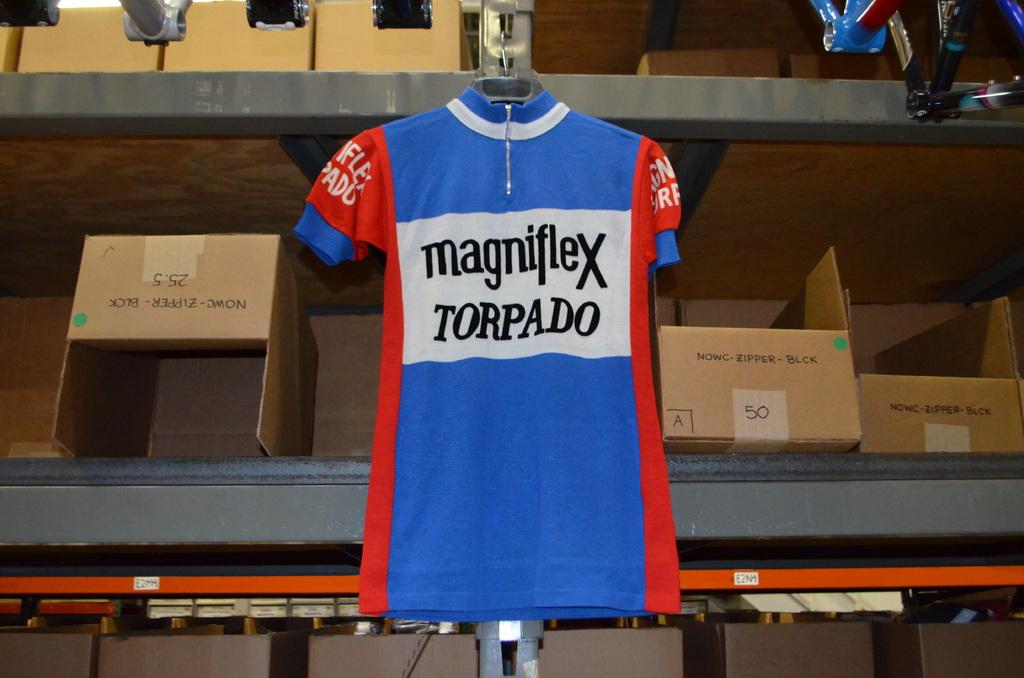Does that shirt say something on it?
Your response must be concise. Yes. What is written on the box to the left of the shirt?
Give a very brief answer. Unanswerable. 